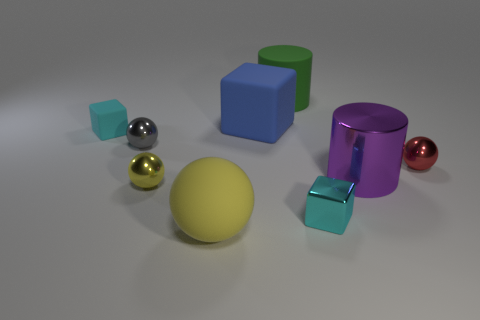Are there more cylinders than red objects?
Offer a terse response. Yes. Is there any other thing of the same color as the big matte cylinder?
Your answer should be compact. No. Are the blue cube and the green object made of the same material?
Keep it short and to the point. Yes. Is the number of balls less than the number of rubber balls?
Provide a succinct answer. No. Is the shape of the cyan rubber object the same as the blue rubber object?
Offer a terse response. Yes. The big ball has what color?
Make the answer very short. Yellow. What number of other things are there of the same material as the red object
Make the answer very short. 4. What number of yellow objects are either metallic balls or large matte spheres?
Keep it short and to the point. 2. There is a yellow object that is behind the small shiny block; is its shape the same as the yellow matte object that is in front of the purple metallic cylinder?
Ensure brevity in your answer.  Yes. There is a metallic block; is its color the same as the cube that is to the left of the yellow rubber object?
Keep it short and to the point. Yes. 